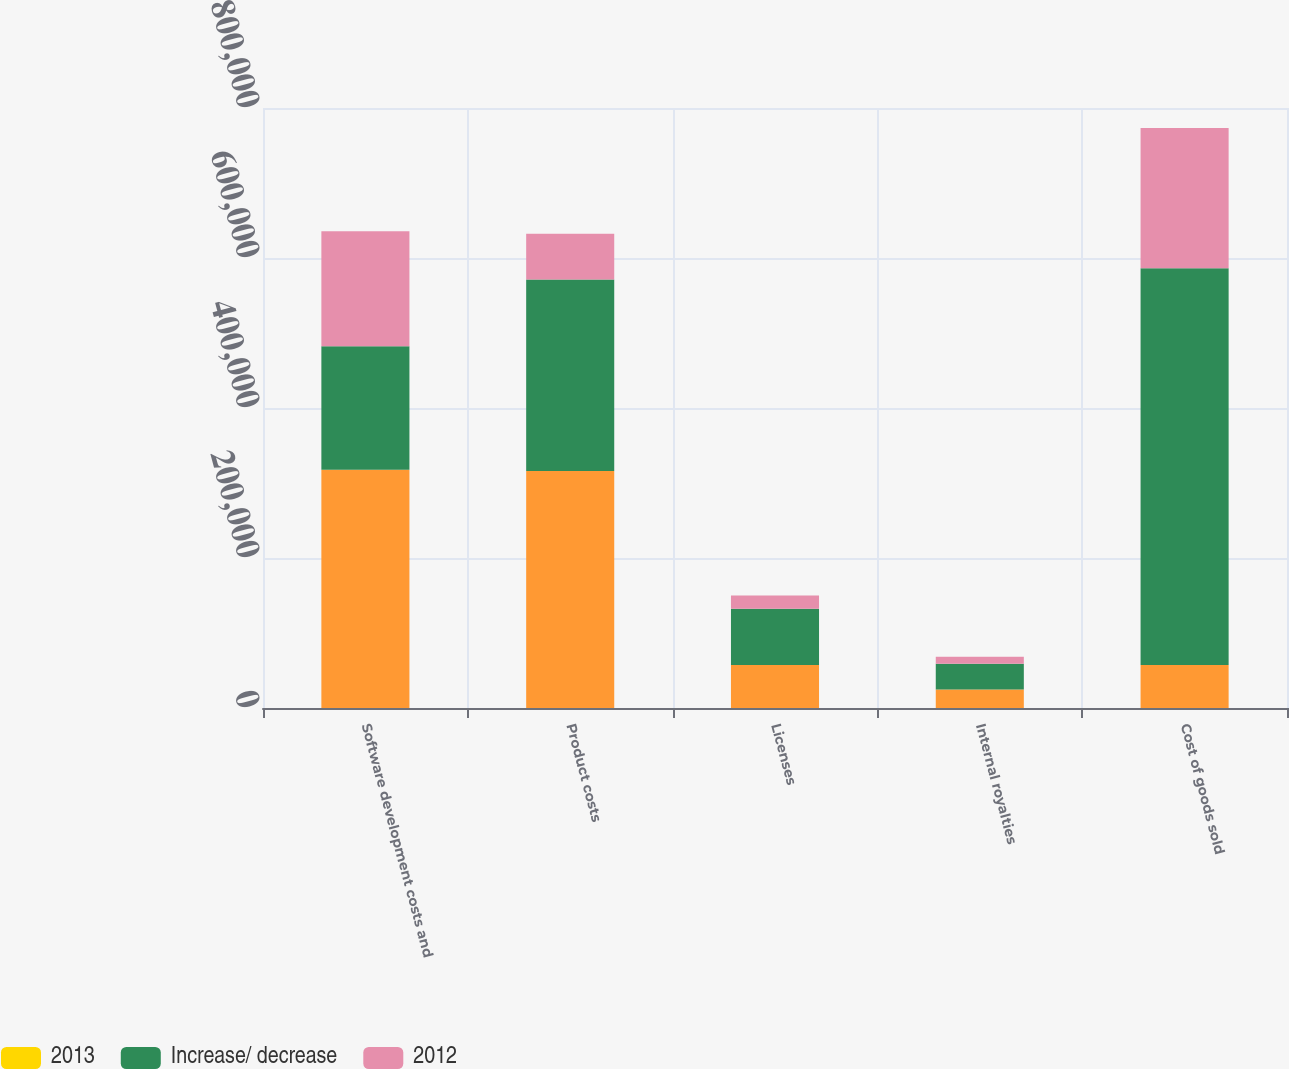Convert chart. <chart><loc_0><loc_0><loc_500><loc_500><stacked_bar_chart><ecel><fcel>Software development costs and<fcel>Product costs<fcel>Licenses<fcel>Internal royalties<fcel>Cost of goods sold<nl><fcel>nan<fcel>317756<fcel>316072<fcel>57285<fcel>24724<fcel>57285<nl><fcel>2013<fcel>26.2<fcel>26<fcel>4.7<fcel>2<fcel>58.9<nl><fcel>Increase/ decrease<fcel>164487<fcel>255236<fcel>74976<fcel>34156<fcel>528855<nl><fcel>2012<fcel>153269<fcel>60836<fcel>17691<fcel>9432<fcel>186982<nl></chart> 